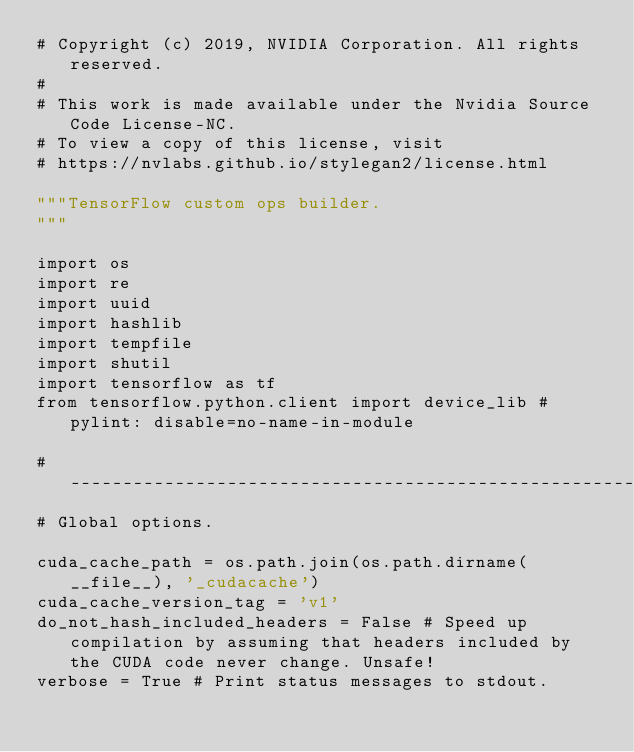Convert code to text. <code><loc_0><loc_0><loc_500><loc_500><_Python_># Copyright (c) 2019, NVIDIA Corporation. All rights reserved.
#
# This work is made available under the Nvidia Source Code License-NC.
# To view a copy of this license, visit
# https://nvlabs.github.io/stylegan2/license.html

"""TensorFlow custom ops builder.
"""

import os
import re
import uuid
import hashlib
import tempfile
import shutil
import tensorflow as tf
from tensorflow.python.client import device_lib # pylint: disable=no-name-in-module

#----------------------------------------------------------------------------
# Global options.

cuda_cache_path = os.path.join(os.path.dirname(__file__), '_cudacache')
cuda_cache_version_tag = 'v1'
do_not_hash_included_headers = False # Speed up compilation by assuming that headers included by the CUDA code never change. Unsafe!
verbose = True # Print status messages to stdout.
</code> 